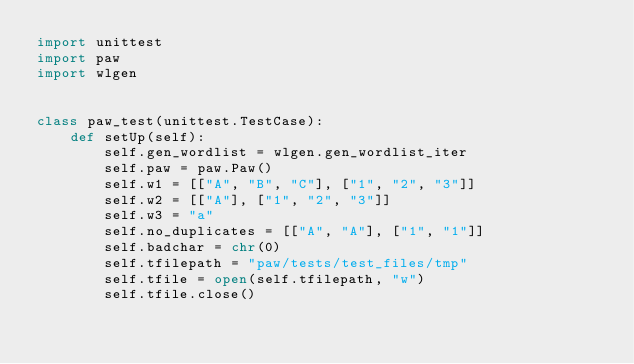Convert code to text. <code><loc_0><loc_0><loc_500><loc_500><_Python_>import unittest
import paw
import wlgen


class paw_test(unittest.TestCase):
    def setUp(self):
        self.gen_wordlist = wlgen.gen_wordlist_iter
        self.paw = paw.Paw()
        self.w1 = [["A", "B", "C"], ["1", "2", "3"]]
        self.w2 = [["A"], ["1", "2", "3"]]
        self.w3 = "a"
        self.no_duplicates = [["A", "A"], ["1", "1"]]
        self.badchar = chr(0)
        self.tfilepath = "paw/tests/test_files/tmp"
        self.tfile = open(self.tfilepath, "w")
        self.tfile.close()
</code> 